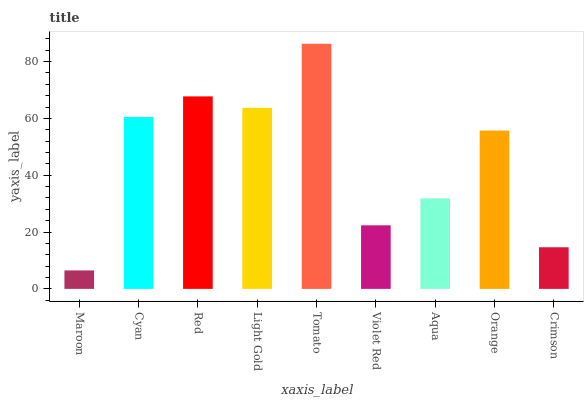Is Cyan the minimum?
Answer yes or no. No. Is Cyan the maximum?
Answer yes or no. No. Is Cyan greater than Maroon?
Answer yes or no. Yes. Is Maroon less than Cyan?
Answer yes or no. Yes. Is Maroon greater than Cyan?
Answer yes or no. No. Is Cyan less than Maroon?
Answer yes or no. No. Is Orange the high median?
Answer yes or no. Yes. Is Orange the low median?
Answer yes or no. Yes. Is Crimson the high median?
Answer yes or no. No. Is Light Gold the low median?
Answer yes or no. No. 